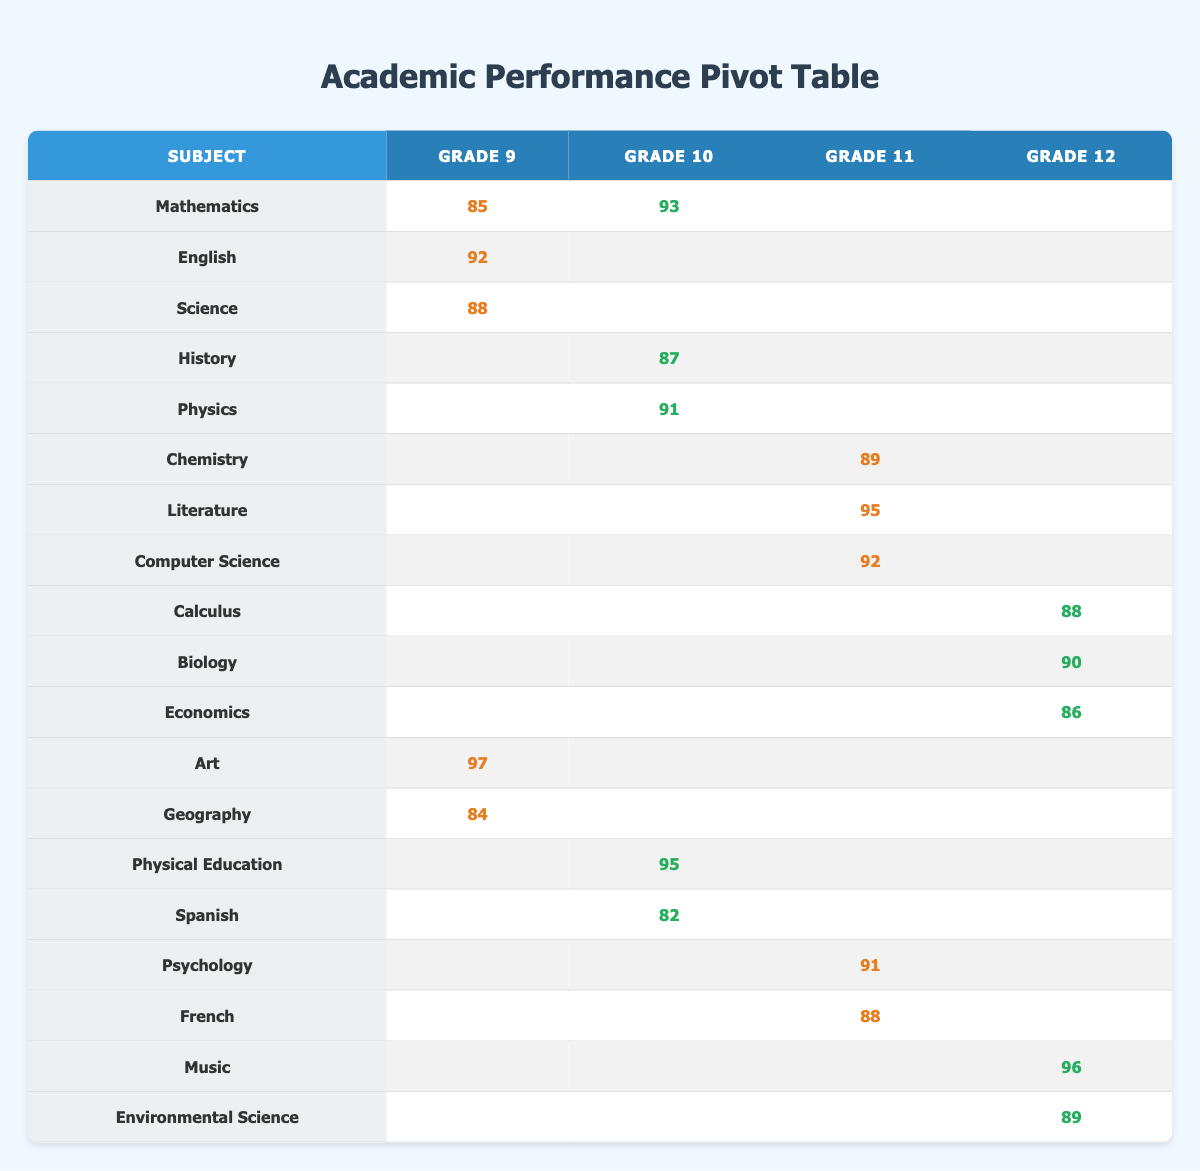What is the highest score in Mathematics for any grade? The highest score for Mathematics is in Grade 10 with a score of 93 from Michael Chen. The Grades 9 and 12 have scores of 85 and unavailable respectively.
Answer: 93 Which student scored the highest in Art? Olivia Parker scored the highest in Art with a score of 97 in Grade 9. The table shows that no other grades have scores for this subject.
Answer: 97 What is the average score for students in Grade 11? To calculate the average for Grade 11, I take the scores from Chemistry (89), Literature (95), Computer Science (92), Psychology (91), and French (88). The total score is 455, and there are 5 subjects, so the average is 455 / 5 = 91.
Answer: 91 Did any student score above 90 in Spanish? No, the only entry in Spanish is by Ethan Williams, who scored 82. Thus, there are no scores above 90 in this subject.
Answer: No What is the difference between the highest and lowest score in Biology? The only Biology score is from David Thompson, who scored 90. Since no other score exists for this subject, the difference between the highest and lowest score is 90 - 90 = 0.
Answer: 0 Who has the lowest score in Grade 10? In Grade 10, looking across subjects, the lowest score is in Spanish where Ethan Williams scored 82. The scores for Physical Education and Mathematics are higher, 95 and 93, respectively.
Answer: 82 Which subject has the most entries across all grades? The subject with the most entries is Mathematics, which has scores for Grade 9 and Grade 10. Other subjects have fewer entries or are exclusive to a single grade. Therefore, it has the most students represented in the table.
Answer: Mathematics Is there a subject in Grade 12 with no entries? Yes, subjects like History, Physics, and Computer Science have no entries for Grade 12, as the only subjects listed for Grade 12 are Calculus, Biology, Economics, Music, and Environmental Science.
Answer: Yes What is the combined total score for all subjects in Grade 9? For Grade 9, the subjects and scores are Mathematics (85), English (92), Science (88), Art (97), and Geography (84). Adding these gives 85 + 92 + 88 + 97 + 84 = 446.
Answer: 446 